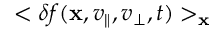Convert formula to latex. <formula><loc_0><loc_0><loc_500><loc_500>< \delta f ( { x } , v _ { \| } , v _ { \perp } , t ) > _ { x }</formula> 